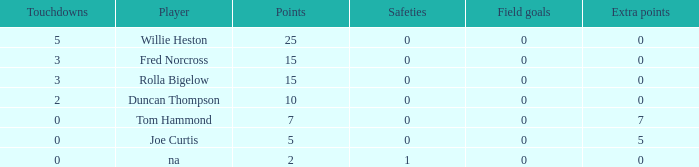How many Touchdowns have a Player of rolla bigelow, and an Extra points smaller than 0? None. 